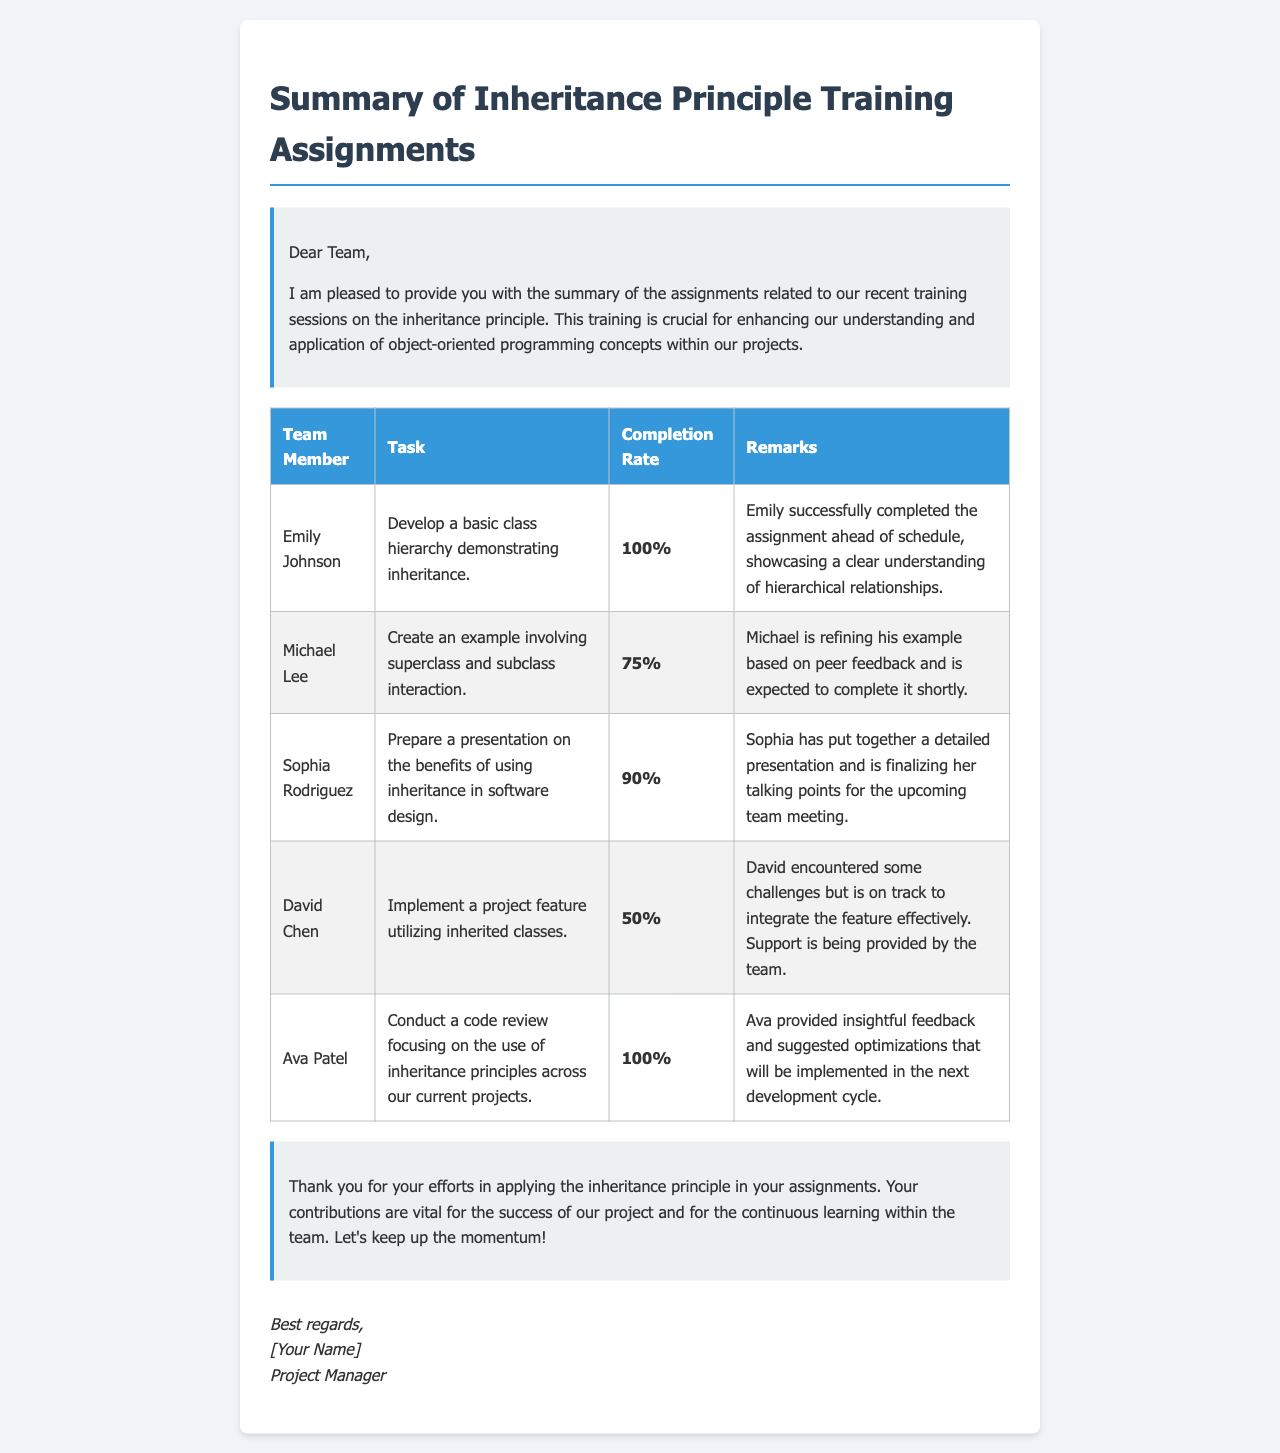What is the title of the document? The title is stated in the heading of the document which summarizes the content related to team members' assignments.
Answer: Summary of Inheritance Principle Training Assignments How many team members completed their assignments with a completion rate of 100%? The table lists the team members and their completion rates, highlighting those who completed at 100%.
Answer: 2 What was Michael Lee's completion rate? The completion rate for Michael Lee is mentioned in the table which summarizes the assignments.
Answer: 75% Which task did Ava Patel undertake? The table provides specific tasks assigned to each team member, including Ava Patel's task related to code review.
Answer: Conduct a code review focusing on the use of inheritance principles across our current projects What percentage represents David Chen's completion rate? The completion rate for David Chen is indicated in the document within the table summarizing assignments.
Answer: 50% What are the remarks for Sophia Rodriguez? The remarks for each team member are included in the table, which provides context on each individual's performance.
Answer: Sophia has put together a detailed presentation and is finalizing her talking points for the upcoming team meeting How did Ava Patel's contribution impact the development cycle? The document includes remarks that describe how team contributions affect project development and future iterations.
Answer: Optimizations that will be implemented in the next development cycle What is the total number of tasks listed in the document? The number of tasks is inferred from the number of entries in the table summarizing assignments.
Answer: 5 